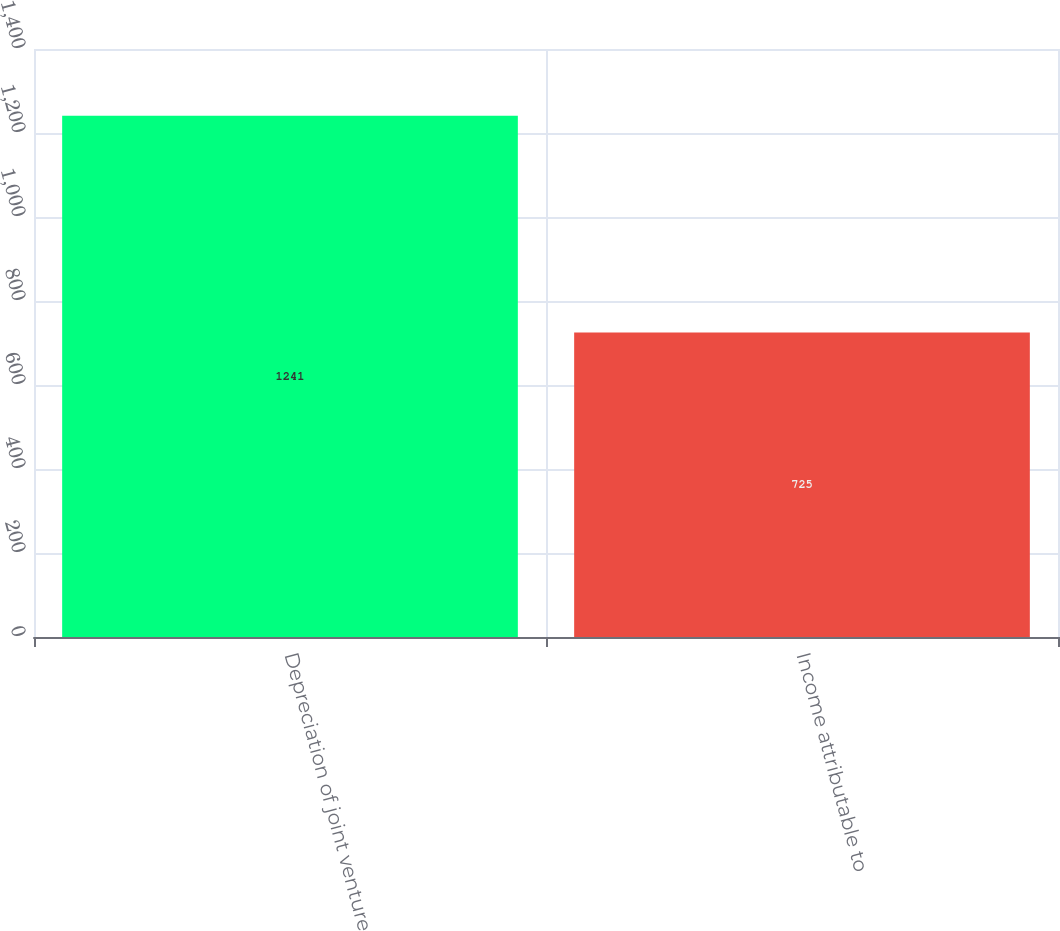Convert chart to OTSL. <chart><loc_0><loc_0><loc_500><loc_500><bar_chart><fcel>Depreciation of joint venture<fcel>Income attributable to<nl><fcel>1241<fcel>725<nl></chart> 